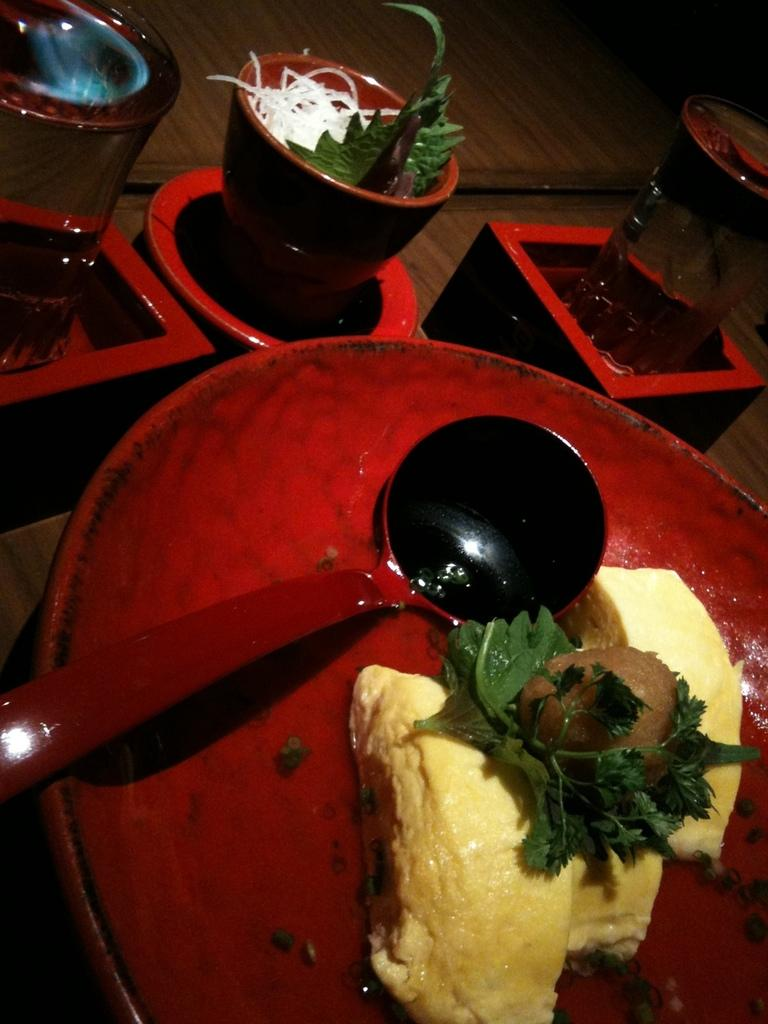What utensil can be seen in the image? There is a spoon in the image. What is the color of the plate that holds food items in the image? The plate that holds food items is red in color. What type of container is present in the image for holding liquids? There are cups in the image for holding liquids. What other objects can be seen on a surface in the image? There are other objects on a surface in the image, but their specific nature is not mentioned in the provided facts. What type of pet is sitting next to the minister in the image? There is no minister or pet present in the image. What type of scarecrow is visible in the image? There is no scarecrow present in the image. 